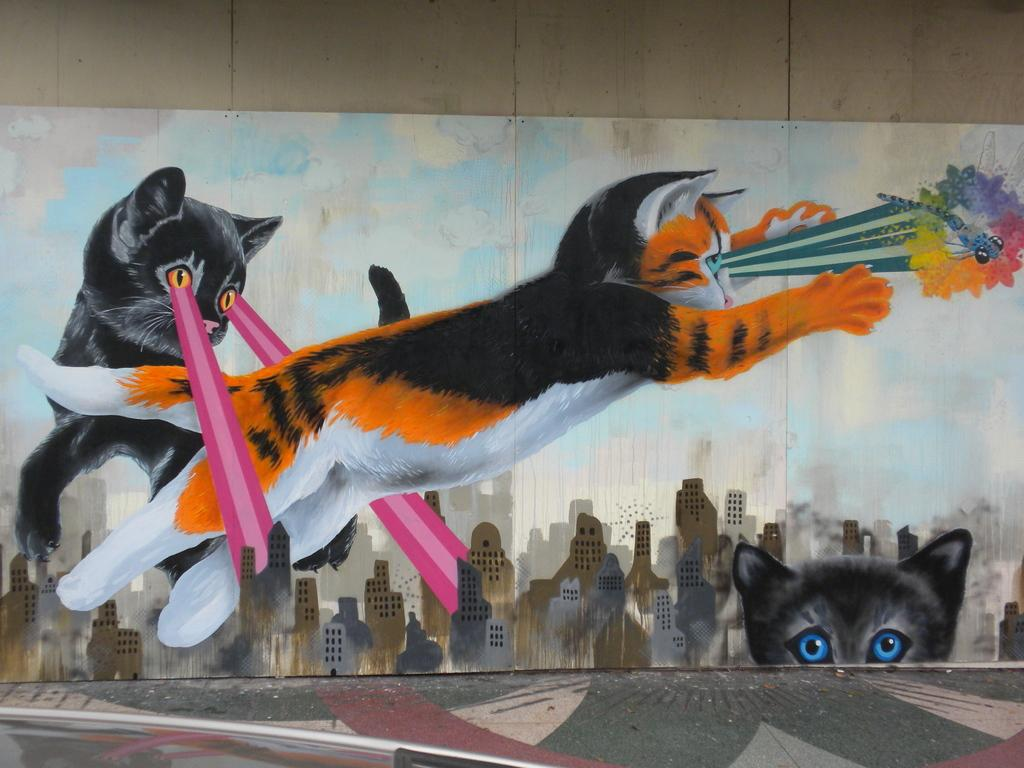What is featured in the image? There is a painting in the image. How is the painting displayed? The painting is on a board. Where is the board with the painting located? The board is attached to a wall. What type of polish is being applied to the church in the image? There is no church or polish present in the image; it features a painting on a board attached to a wall. What is the middle of the painting showing in the image? The provided facts do not give information about the content or composition of the painting, so it is not possible to answer that question. 